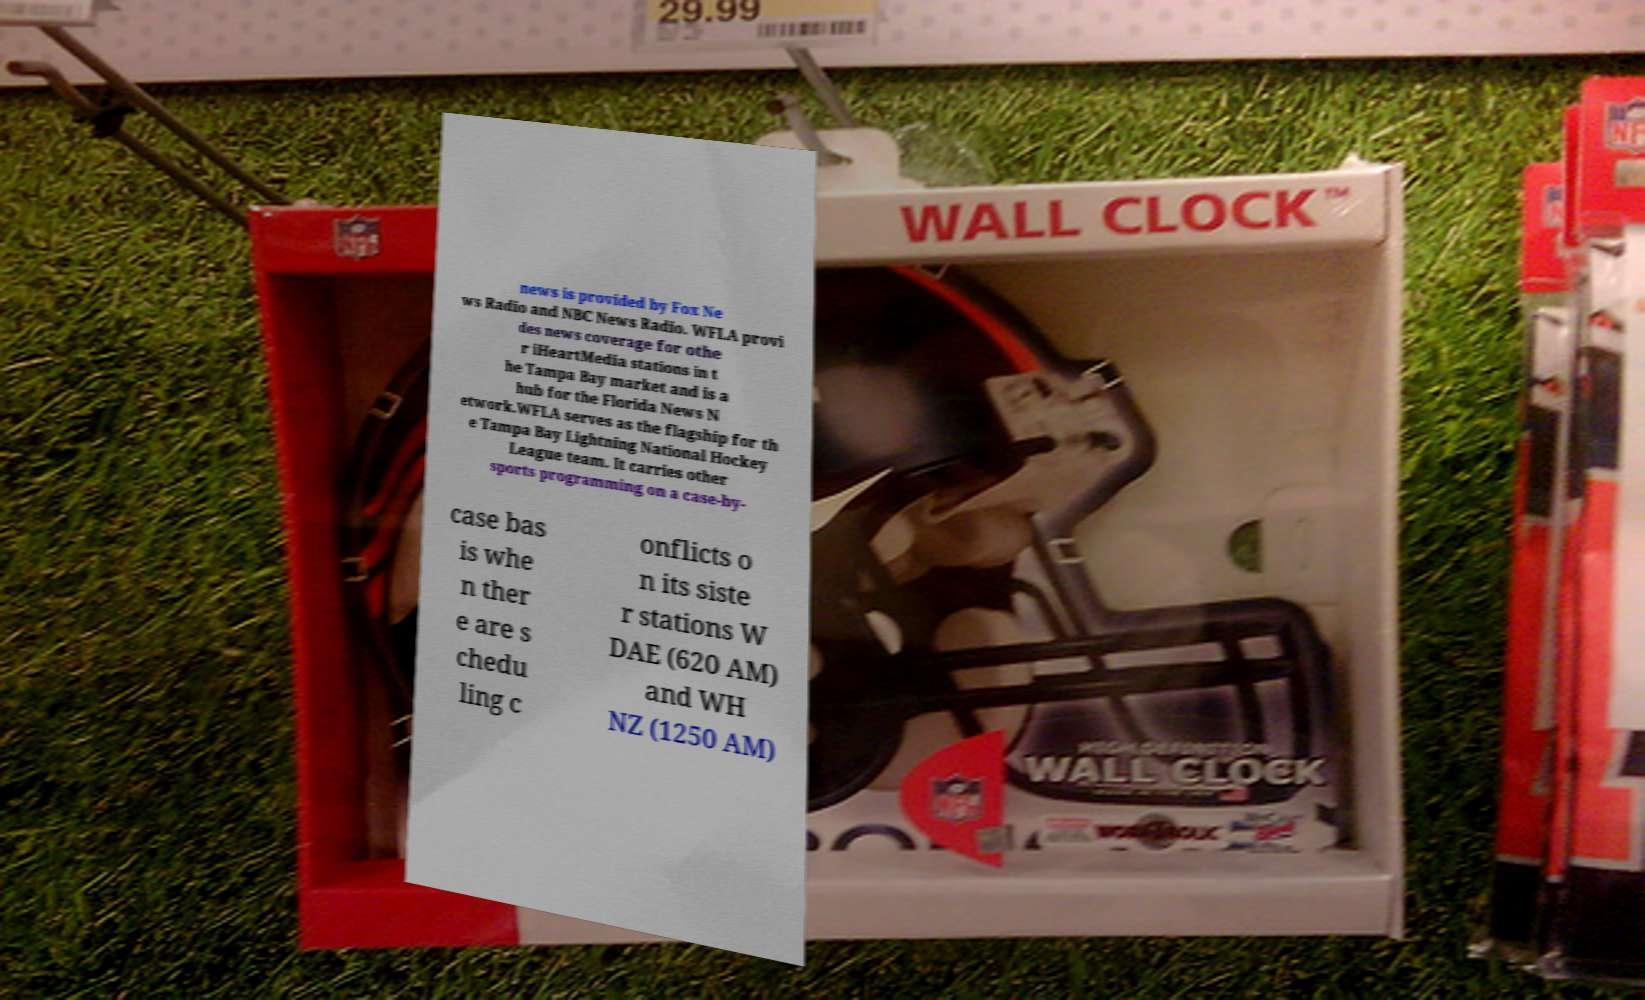Could you extract and type out the text from this image? news is provided by Fox Ne ws Radio and NBC News Radio. WFLA provi des news coverage for othe r iHeartMedia stations in t he Tampa Bay market and is a hub for the Florida News N etwork.WFLA serves as the flagship for th e Tampa Bay Lightning National Hockey League team. It carries other sports programming on a case-by- case bas is whe n ther e are s chedu ling c onflicts o n its siste r stations W DAE (620 AM) and WH NZ (1250 AM) 